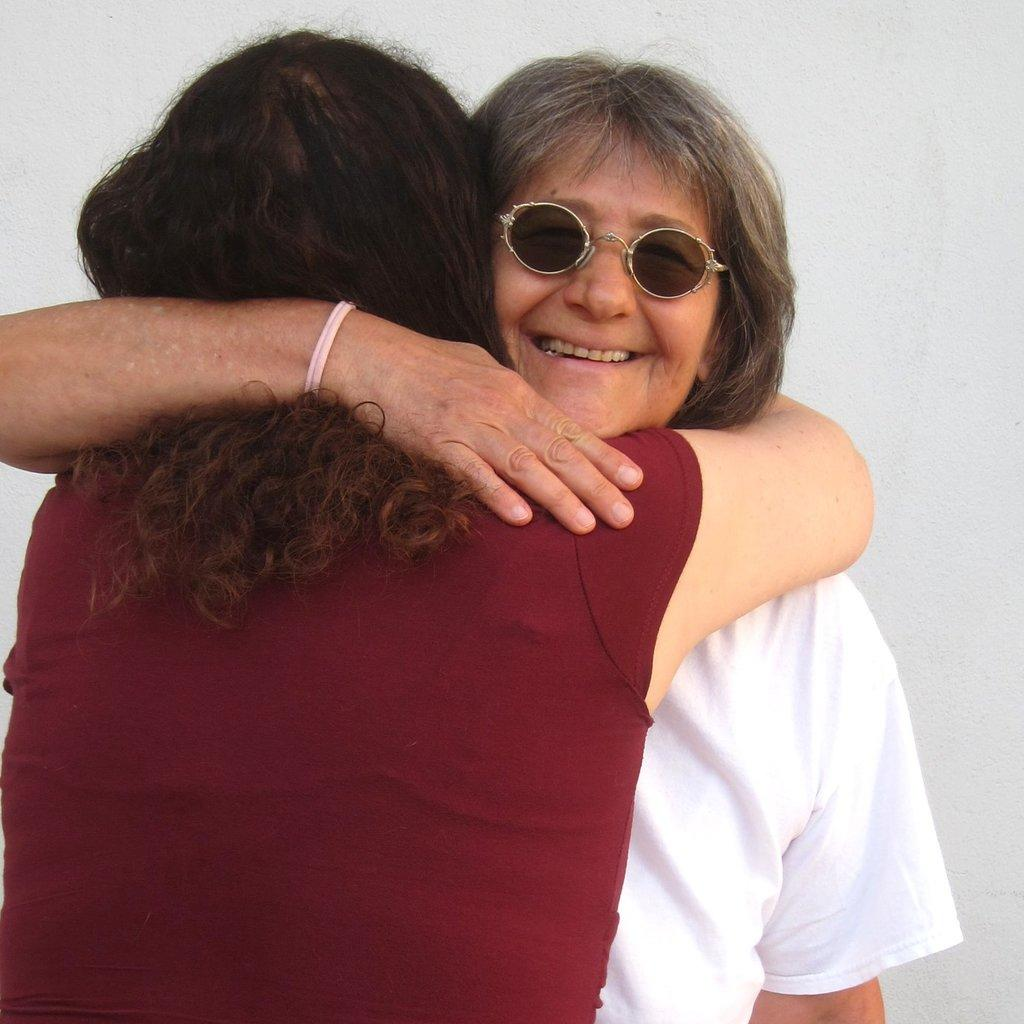How many people are in the foreground of the image? There are two women in the foreground of the image. What are the women doing in the image? The women are hugging each other. What can be seen in the background of the image? There is a wall in the background of the image. What time is displayed on the clock in the image? There is no clock present in the image. How does the earthquake affect the women in the image? There is no earthquake depicted in the image; the women are simply hugging each other. 